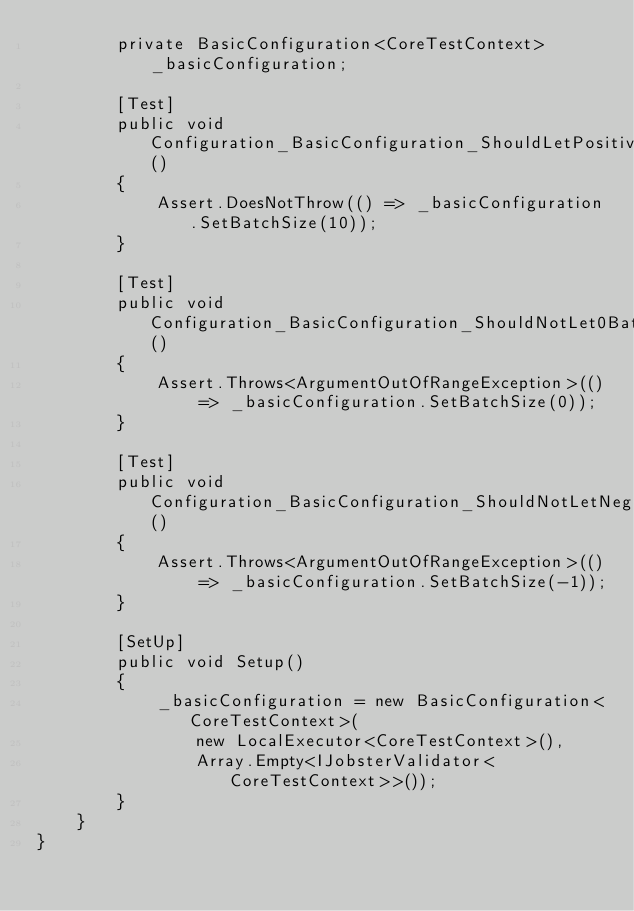<code> <loc_0><loc_0><loc_500><loc_500><_C#_>        private BasicConfiguration<CoreTestContext> _basicConfiguration;

        [Test]
        public void Configuration_BasicConfiguration_ShouldLetPositiveBatchSize()
        {
            Assert.DoesNotThrow(() => _basicConfiguration.SetBatchSize(10));
        }

        [Test]
        public void Configuration_BasicConfiguration_ShouldNotLet0BatchSize()
        {
            Assert.Throws<ArgumentOutOfRangeException>(() => _basicConfiguration.SetBatchSize(0));
        }

        [Test]
        public void Configuration_BasicConfiguration_ShouldNotLetNegativeBatchSize()
        {
            Assert.Throws<ArgumentOutOfRangeException>(() => _basicConfiguration.SetBatchSize(-1));
        }

        [SetUp]
        public void Setup()
        {
            _basicConfiguration = new BasicConfiguration<CoreTestContext>(
                new LocalExecutor<CoreTestContext>(),
                Array.Empty<IJobsterValidator<CoreTestContext>>());
        }
    }
}</code> 